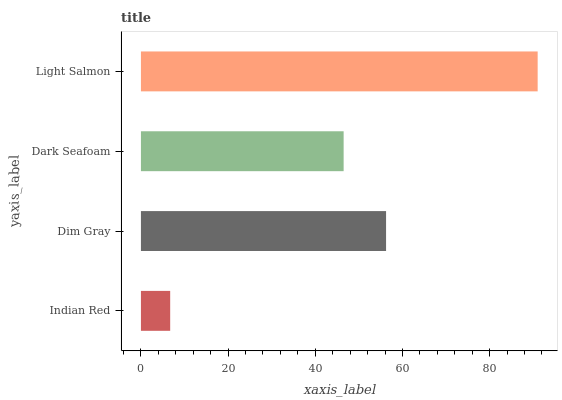Is Indian Red the minimum?
Answer yes or no. Yes. Is Light Salmon the maximum?
Answer yes or no. Yes. Is Dim Gray the minimum?
Answer yes or no. No. Is Dim Gray the maximum?
Answer yes or no. No. Is Dim Gray greater than Indian Red?
Answer yes or no. Yes. Is Indian Red less than Dim Gray?
Answer yes or no. Yes. Is Indian Red greater than Dim Gray?
Answer yes or no. No. Is Dim Gray less than Indian Red?
Answer yes or no. No. Is Dim Gray the high median?
Answer yes or no. Yes. Is Dark Seafoam the low median?
Answer yes or no. Yes. Is Indian Red the high median?
Answer yes or no. No. Is Light Salmon the low median?
Answer yes or no. No. 